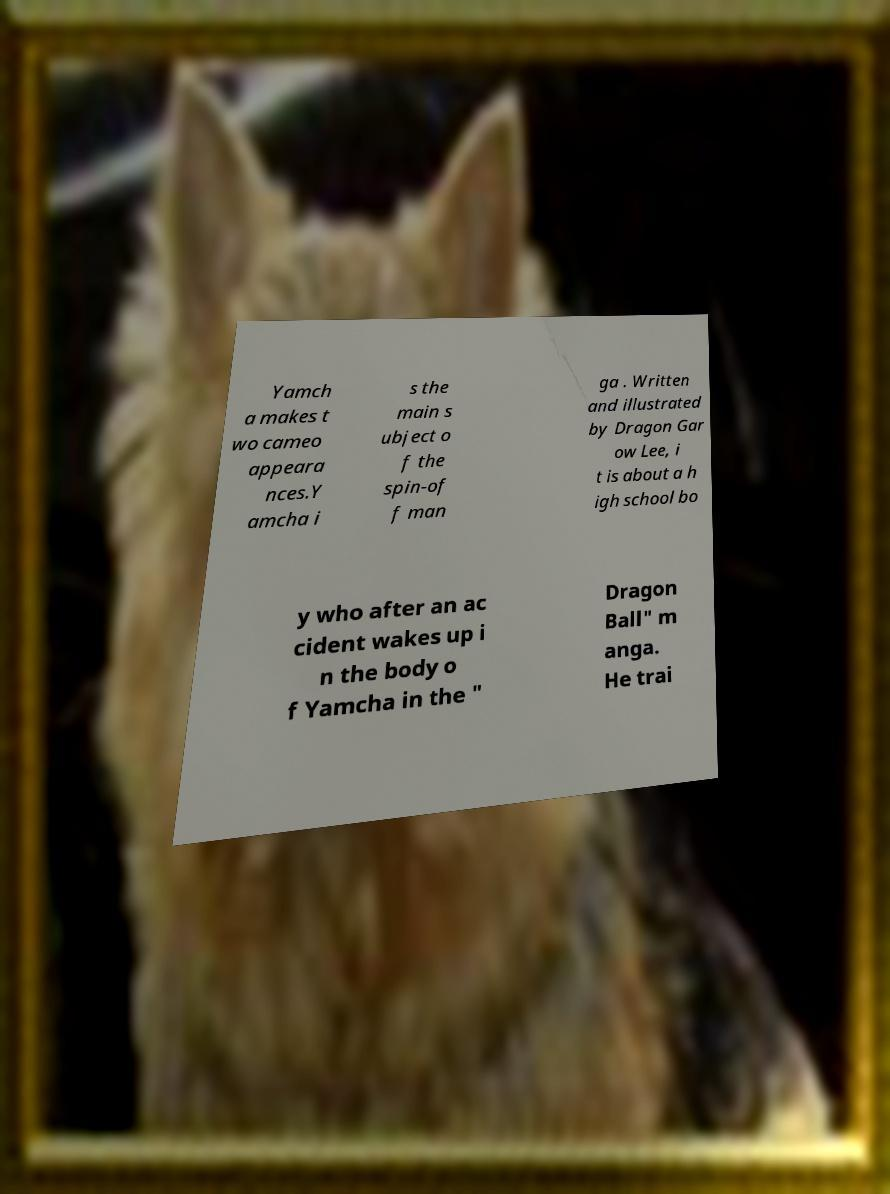Please identify and transcribe the text found in this image. Yamch a makes t wo cameo appeara nces.Y amcha i s the main s ubject o f the spin-of f man ga . Written and illustrated by Dragon Gar ow Lee, i t is about a h igh school bo y who after an ac cident wakes up i n the body o f Yamcha in the " Dragon Ball" m anga. He trai 